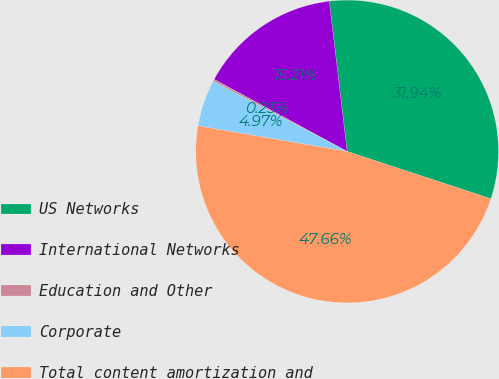Convert chart. <chart><loc_0><loc_0><loc_500><loc_500><pie_chart><fcel>US Networks<fcel>International Networks<fcel>Education and Other<fcel>Corporate<fcel>Total content amortization and<nl><fcel>31.94%<fcel>15.21%<fcel>0.23%<fcel>4.97%<fcel>47.66%<nl></chart> 